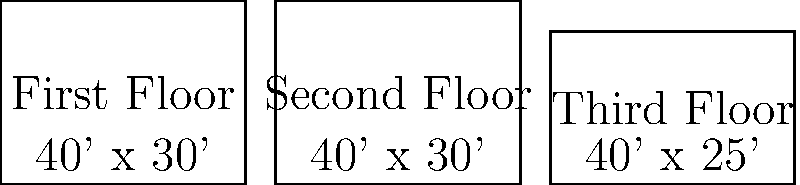Based on the floor plans shown, calculate the total square footage of this three-story house. Round your answer to the nearest whole number. To calculate the total square footage of the house, we need to:

1. Calculate the area of each floor:
   First Floor: $40 \text{ ft} \times 30 \text{ ft} = 1200 \text{ sq ft}$
   Second Floor: $40 \text{ ft} \times 30 \text{ ft} = 1200 \text{ sq ft}$
   Third Floor: $40 \text{ ft} \times 25 \text{ ft} = 1000 \text{ sq ft}$

2. Sum up the areas of all floors:
   $\text{Total Area} = 1200 \text{ sq ft} + 1200 \text{ sq ft} + 1000 \text{ sq ft} = 3400 \text{ sq ft}$

3. The question asks to round to the nearest whole number, but 3400 is already a whole number, so no rounding is necessary.

Therefore, the total square footage of the three-story house is 3400 square feet.
Answer: 3400 sq ft 